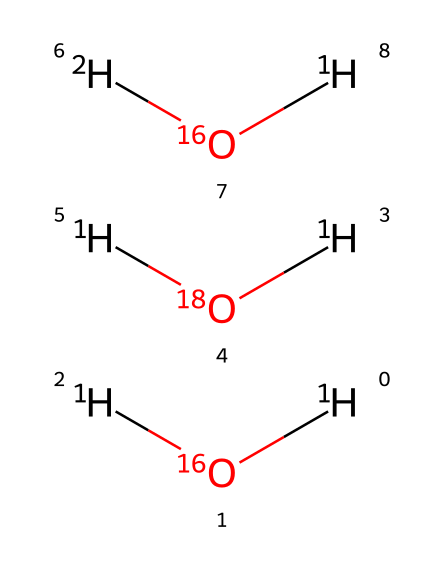What is the number of hydrogen atoms in the chemical? The chemical representation indicates three distinct water molecules, where each water molecule comprises two hydrogen atoms. Therefore, the total number of hydrogen atoms across all molecules is three times two, resulting in a total of six.
Answer: six How many different isotopes of oxygen are present? The chemical shows two distinct oxygen isotopes indicated by their respective atomic weights: 16 and 18. Thus, there are two different oxygen isotopes present in this compound.
Answer: two Which isotope of hydrogen is present alongside the oxygen-18? The chemical representation indicates that the water molecule with oxygen-18 contains regular hydrogen atoms, and since no deuterium (heavy hydrogen) is shown connected with it, the isotope of hydrogen present is protium, represented simply as hydrogen-1.
Answer: hydrogen-1 What fraction of the water molecules contain deuterium? In the chemical structure, there's one water molecule represented with deuterium (the heavy hydrogen), while there are a total of three water molecules (including those with hydrogen-1). This results in a fraction of one out of three, or one-third of the water molecules containing deuterium.
Answer: one-third What does the presence of isotopes in local groundwater signify about its source? The presence of both oxygen-16 and oxygen-18 isotopes indicates that the groundwater has varied origins, as these isotopes can reflect climatic conditions during formation, such as temperatures and evaporation levels. This variation can infer the geochemical history influencing the water.
Answer: varied origins How does the ratio of oxygen isotopes relate to climate? The ratio of oxygen-18 to oxygen-16 in water can provide insights into past temperatures, as heavier isotopes evaporate more slowly in warmer conditions and may concentrate in the remaining water. Thus, analyzing the ratio helps reconstruct climatic history.
Answer: reconstruct climatic history 